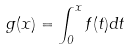Convert formula to latex. <formula><loc_0><loc_0><loc_500><loc_500>g ( x ) = \int _ { 0 } ^ { x } f ( t ) d t</formula> 